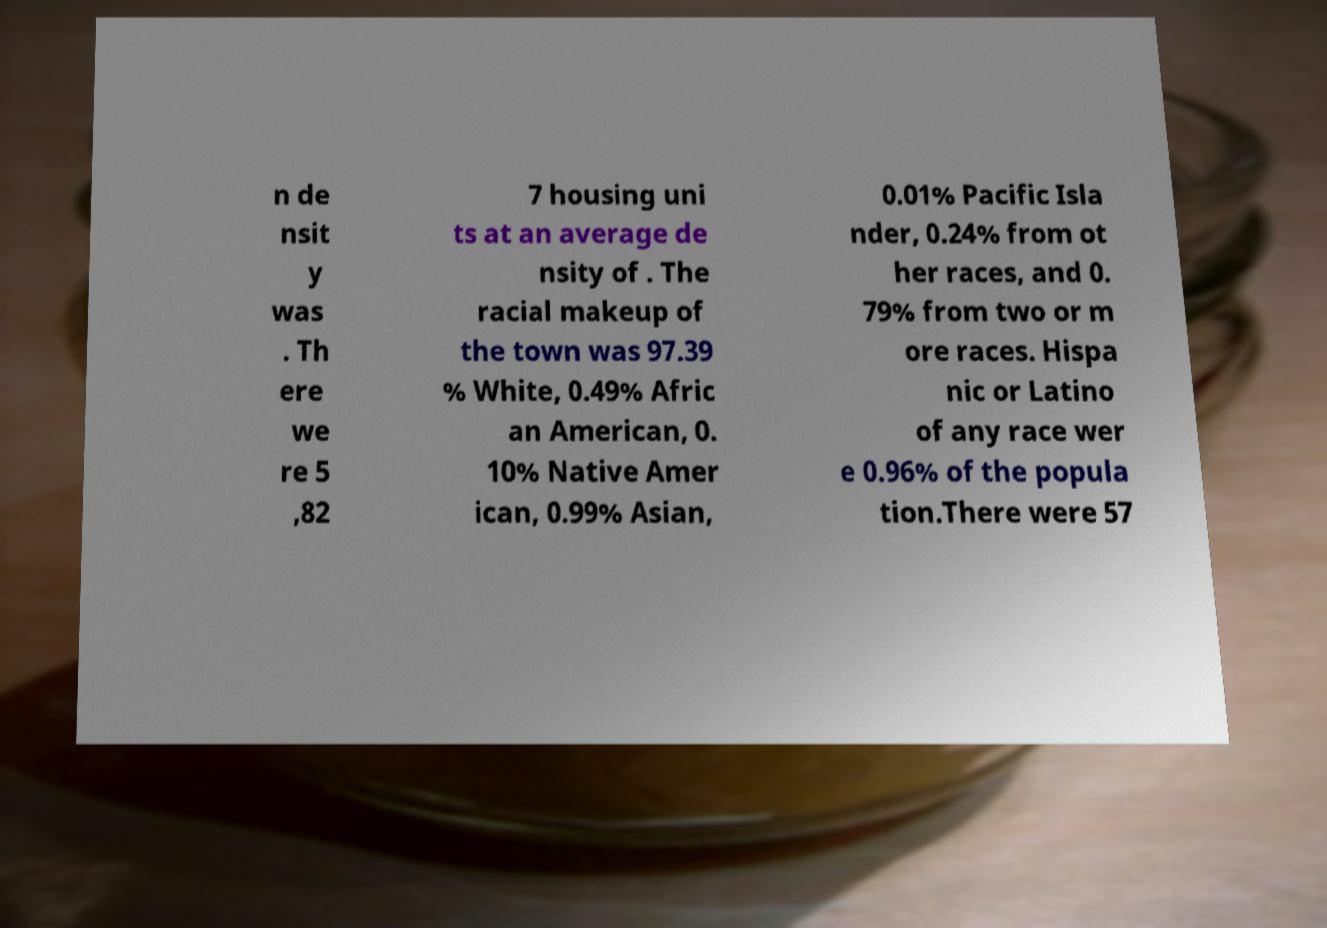There's text embedded in this image that I need extracted. Can you transcribe it verbatim? n de nsit y was . Th ere we re 5 ,82 7 housing uni ts at an average de nsity of . The racial makeup of the town was 97.39 % White, 0.49% Afric an American, 0. 10% Native Amer ican, 0.99% Asian, 0.01% Pacific Isla nder, 0.24% from ot her races, and 0. 79% from two or m ore races. Hispa nic or Latino of any race wer e 0.96% of the popula tion.There were 57 